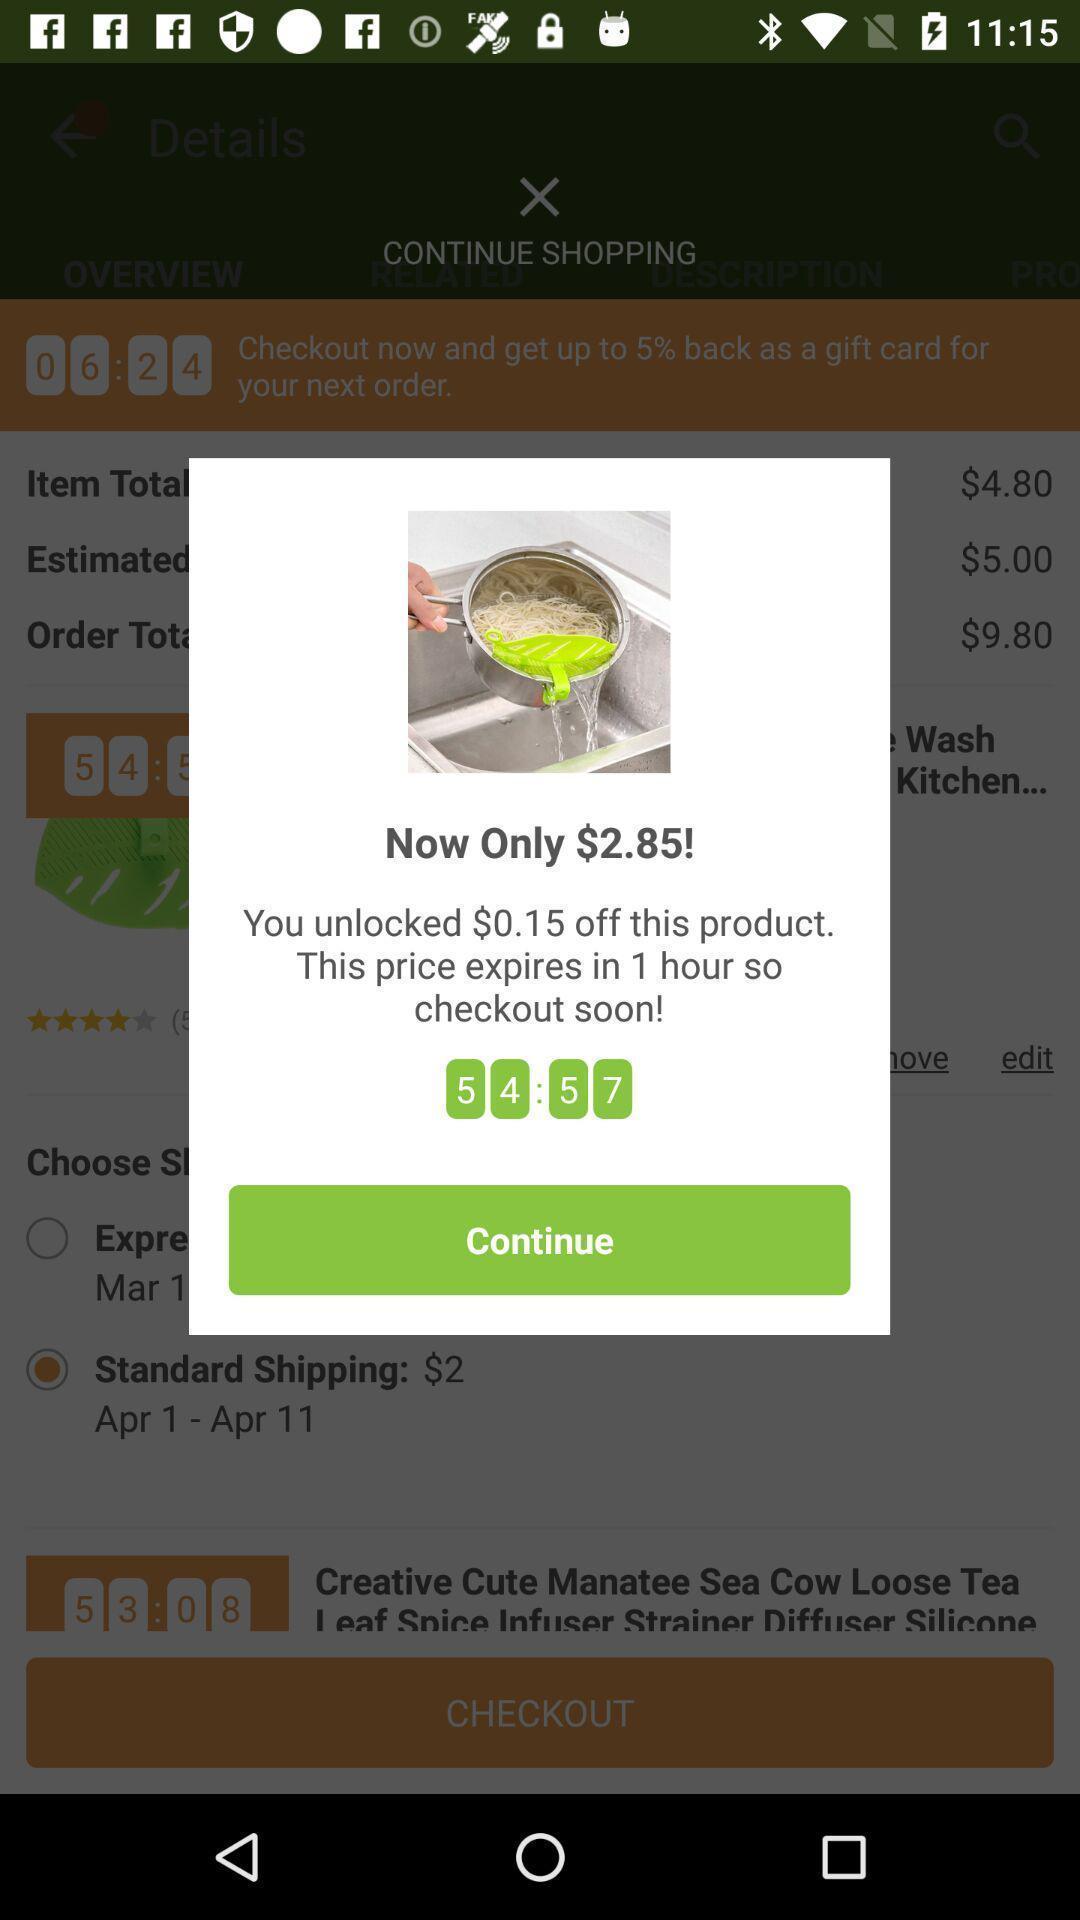Give me a summary of this screen capture. Popup page showing offer price of product in shopping app. 